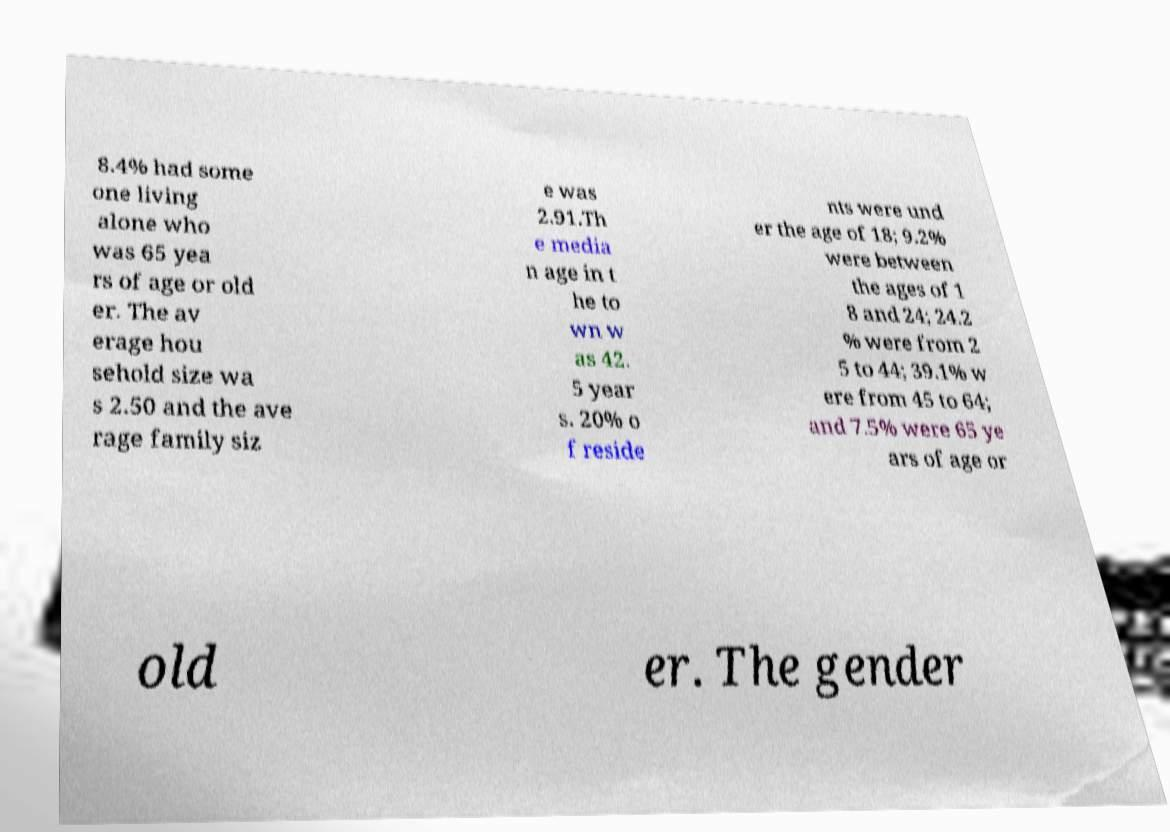Could you assist in decoding the text presented in this image and type it out clearly? 8.4% had some one living alone who was 65 yea rs of age or old er. The av erage hou sehold size wa s 2.50 and the ave rage family siz e was 2.91.Th e media n age in t he to wn w as 42. 5 year s. 20% o f reside nts were und er the age of 18; 9.2% were between the ages of 1 8 and 24; 24.2 % were from 2 5 to 44; 39.1% w ere from 45 to 64; and 7.5% were 65 ye ars of age or old er. The gender 